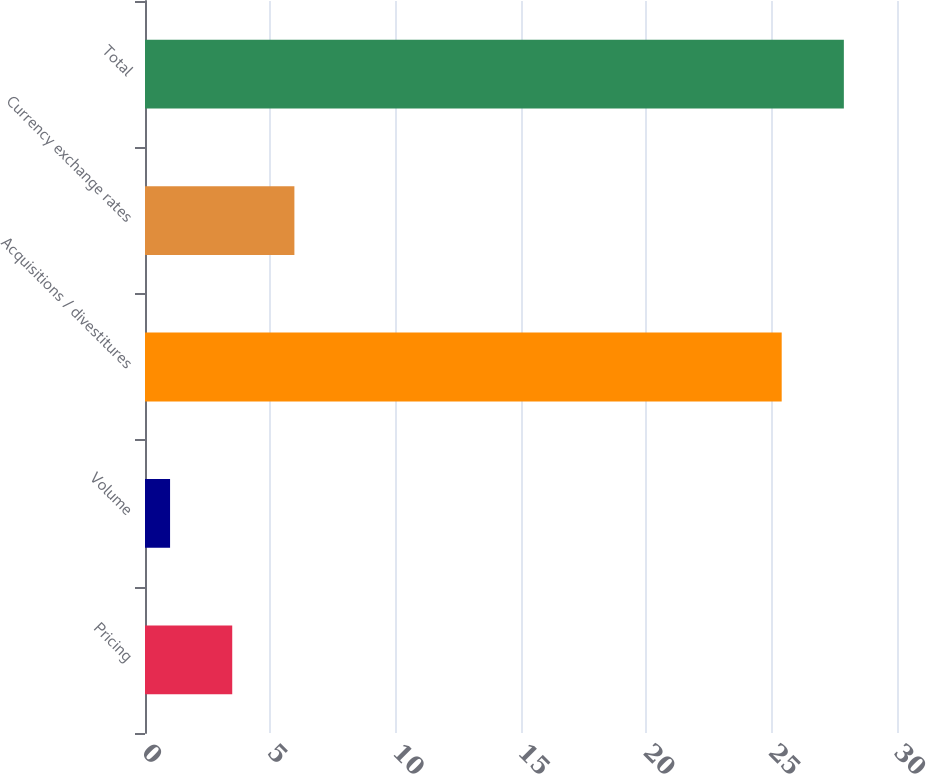<chart> <loc_0><loc_0><loc_500><loc_500><bar_chart><fcel>Pricing<fcel>Volume<fcel>Acquisitions / divestitures<fcel>Currency exchange rates<fcel>Total<nl><fcel>3.48<fcel>1<fcel>25.4<fcel>5.96<fcel>27.88<nl></chart> 